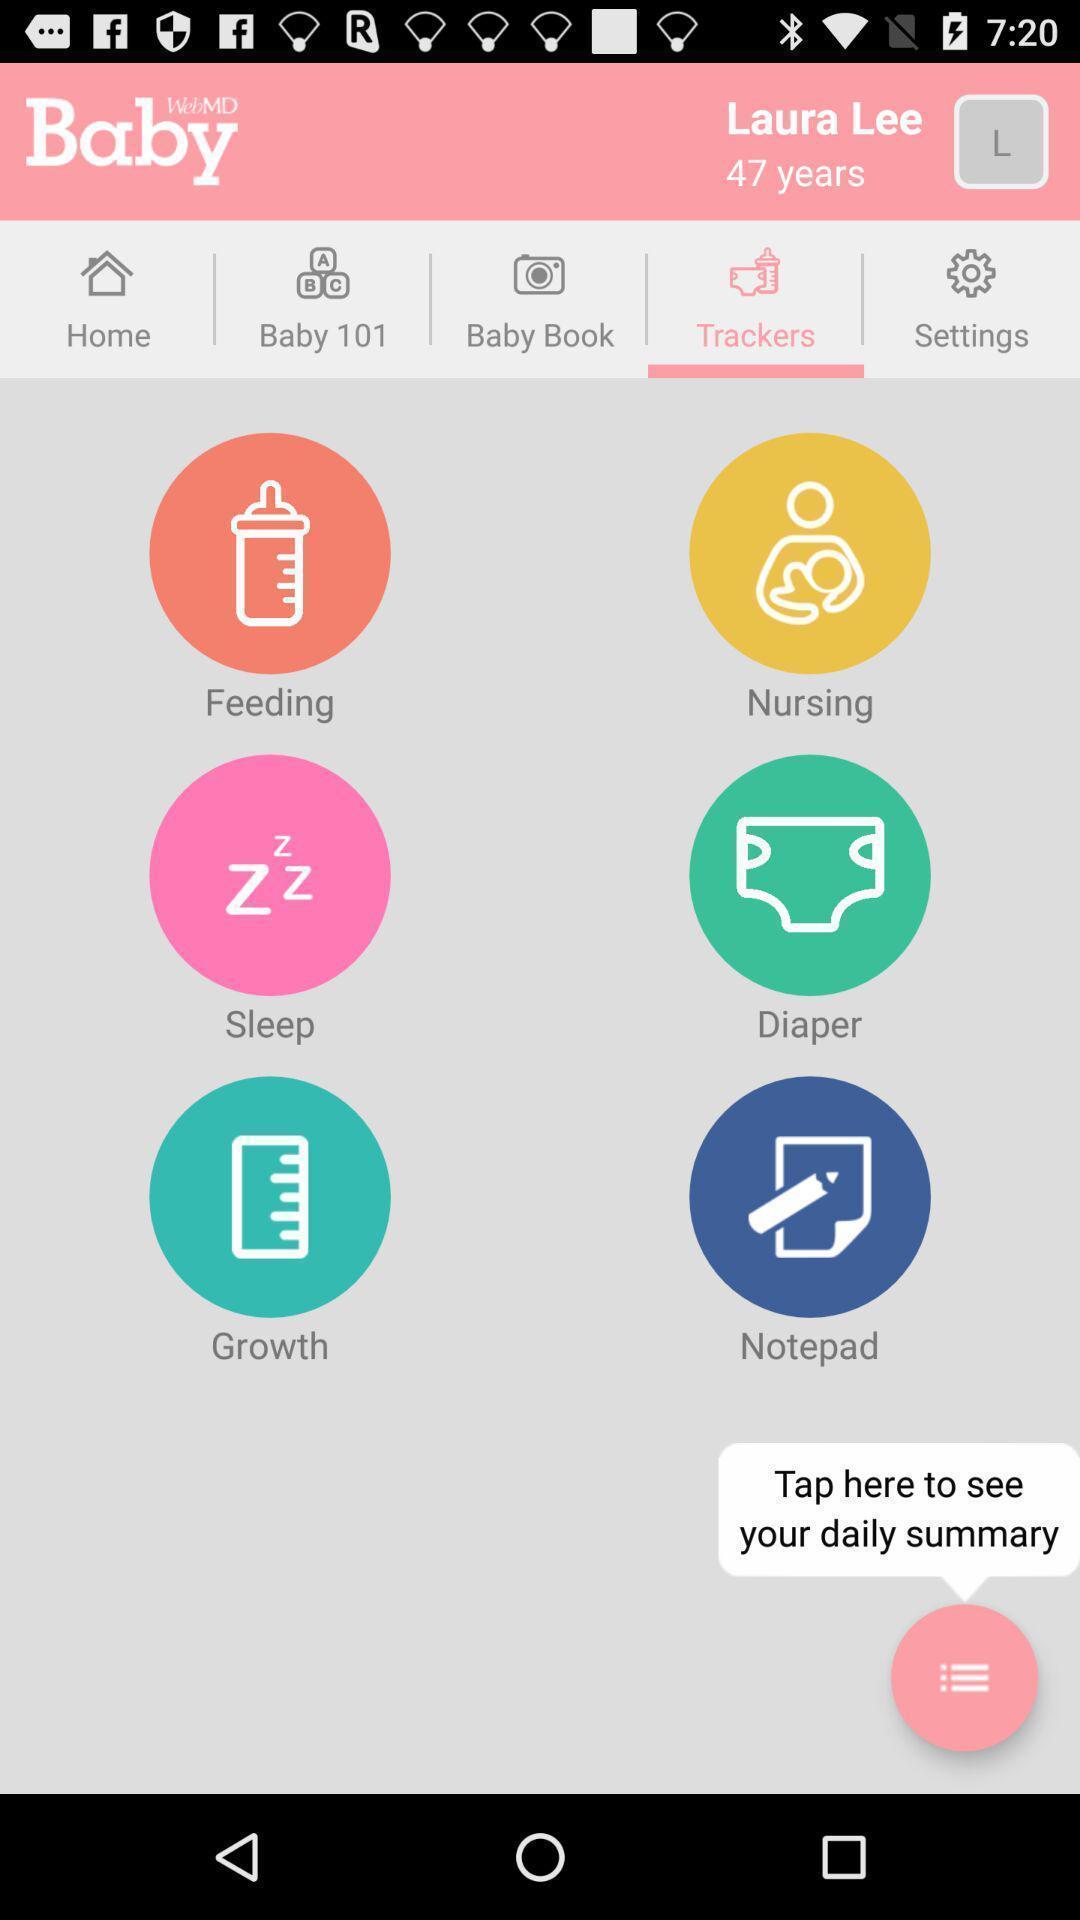Describe this image in words. Tracking page in a baby health care app. 